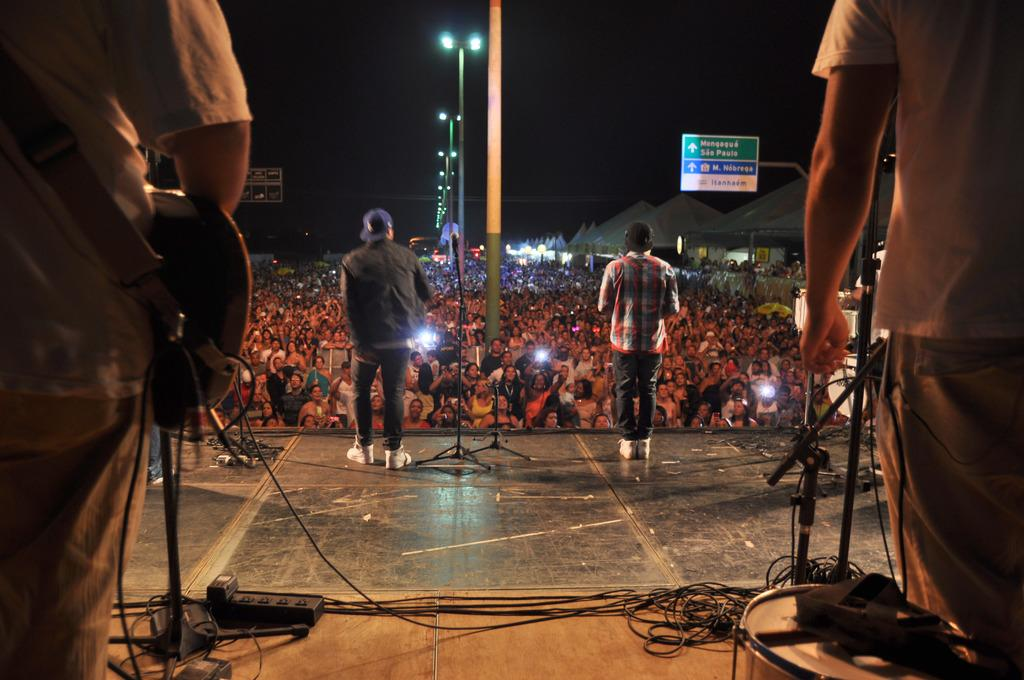How many people are on stage in the image? There are four persons on stage in the image. What is the relationship between the people on stage and the audience? The people on stage are performing or presenting, while the audience is there to watch or listen. What type of plantation can be seen in the background of the image? There is no plantation visible in the image; it features a stage with performers and an audience. Is there a kitty wearing a crown on stage in the image? No, there are no animals or crowns present on stage in the image. 